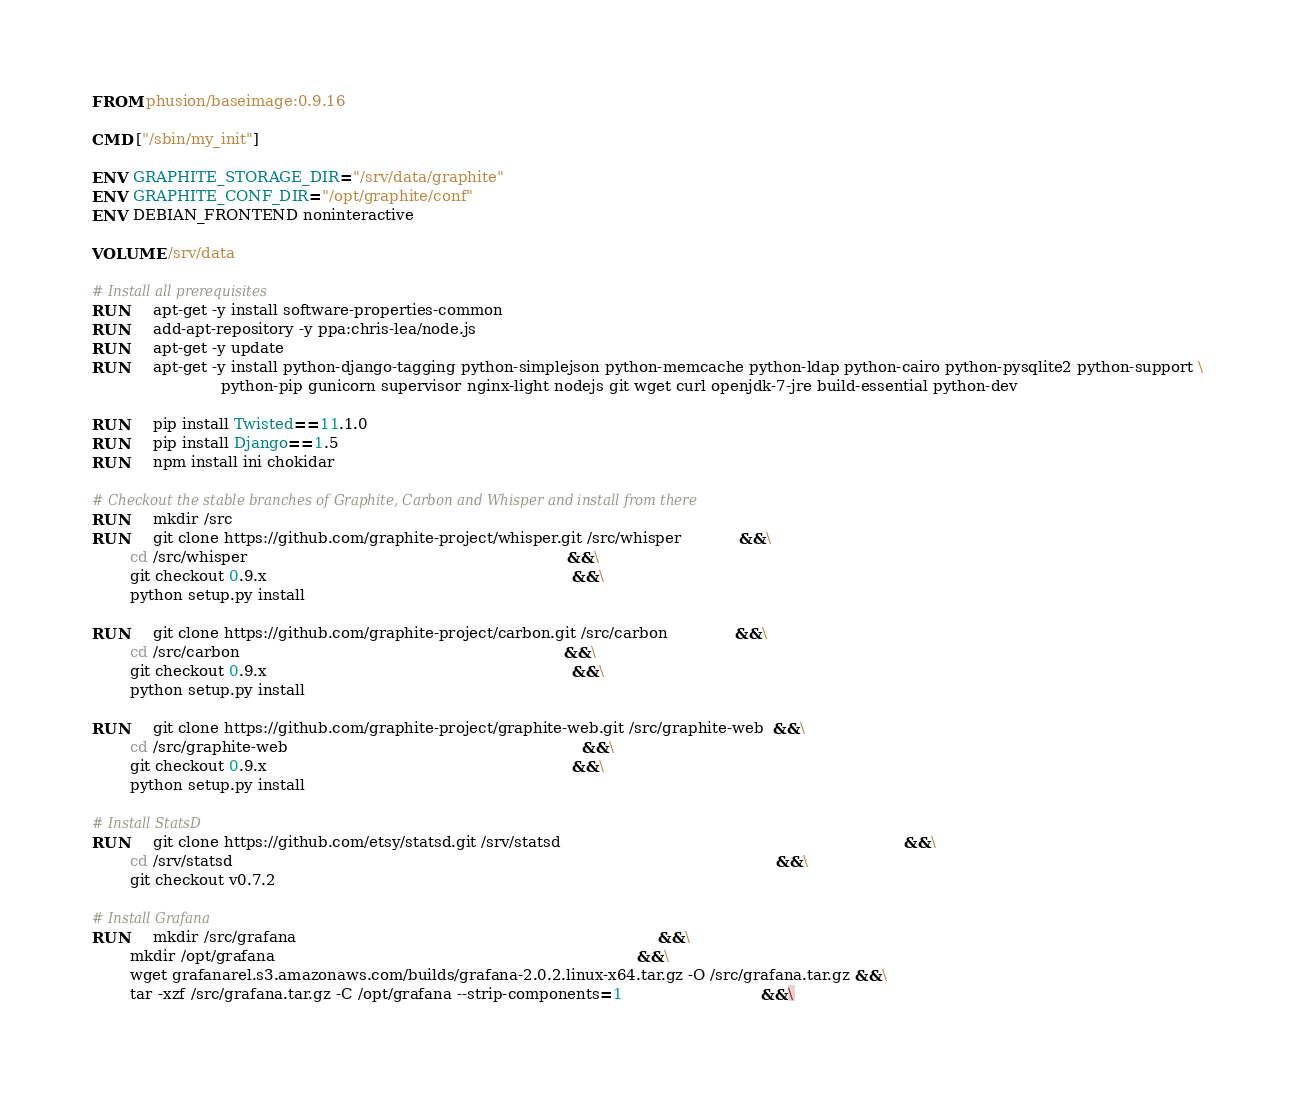Convert code to text. <code><loc_0><loc_0><loc_500><loc_500><_Dockerfile_>FROM phusion/baseimage:0.9.16

CMD ["/sbin/my_init"]

ENV GRAPHITE_STORAGE_DIR="/srv/data/graphite"
ENV GRAPHITE_CONF_DIR="/opt/graphite/conf"
ENV DEBIAN_FRONTEND noninteractive

VOLUME /srv/data

# Install all prerequisites
RUN     apt-get -y install software-properties-common
RUN     add-apt-repository -y ppa:chris-lea/node.js
RUN     apt-get -y update
RUN     apt-get -y install python-django-tagging python-simplejson python-memcache python-ldap python-cairo python-pysqlite2 python-support \
                           python-pip gunicorn supervisor nginx-light nodejs git wget curl openjdk-7-jre build-essential python-dev

RUN     pip install Twisted==11.1.0
RUN     pip install Django==1.5
RUN     npm install ini chokidar

# Checkout the stable branches of Graphite, Carbon and Whisper and install from there
RUN     mkdir /src
RUN     git clone https://github.com/graphite-project/whisper.git /src/whisper            &&\
        cd /src/whisper                                                                   &&\
        git checkout 0.9.x                                                                &&\
        python setup.py install

RUN     git clone https://github.com/graphite-project/carbon.git /src/carbon              &&\
        cd /src/carbon                                                                    &&\
        git checkout 0.9.x                                                                &&\
        python setup.py install

RUN     git clone https://github.com/graphite-project/graphite-web.git /src/graphite-web  &&\
        cd /src/graphite-web                                                              &&\
        git checkout 0.9.x                                                                &&\
        python setup.py install

# Install StatsD
RUN     git clone https://github.com/etsy/statsd.git /srv/statsd                                                                        &&\
        cd /srv/statsd                                                                                                                  &&\
        git checkout v0.7.2

# Install Grafana
RUN     mkdir /src/grafana                                                                            &&\
        mkdir /opt/grafana                                                                            &&\
        wget grafanarel.s3.amazonaws.com/builds/grafana-2.0.2.linux-x64.tar.gz -O /src/grafana.tar.gz &&\
        tar -xzf /src/grafana.tar.gz -C /opt/grafana --strip-components=1                             &&\</code> 